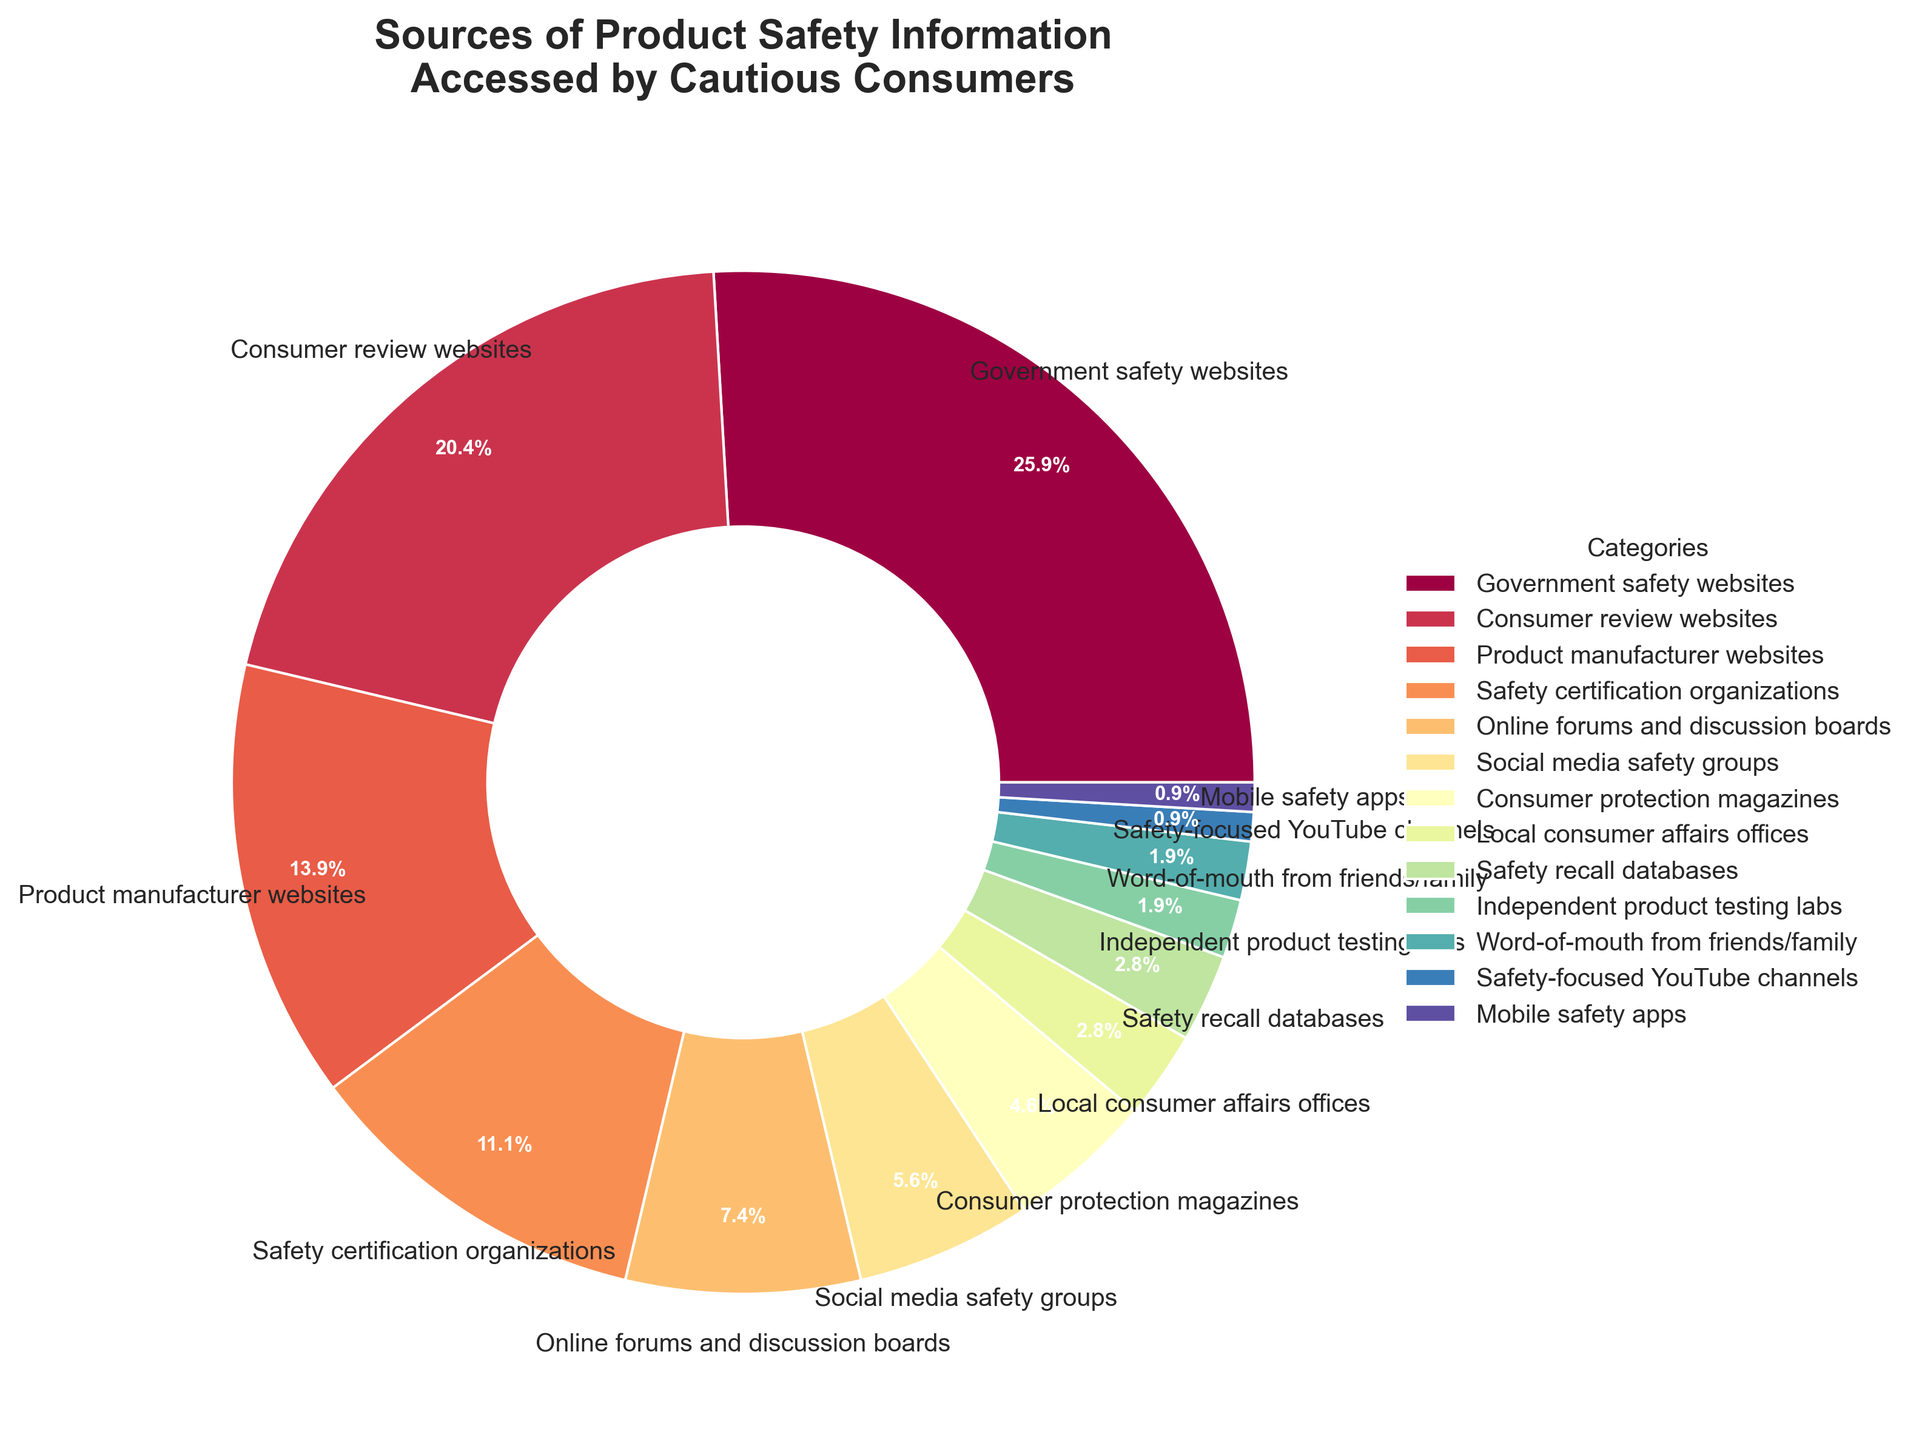What is the most common source of product safety information accessed by cautious consumers? The largest segment in the pie chart represents the most common source. The "Government safety websites" section is the largest at 28%.
Answer: Government safety websites How much more popular are Consumer review websites compared to Product manufacturer websites as sources of product safety information? Compare the percentages for "Consumer review websites" and "Product manufacturer websites". Consumer review websites are at 22% and Product manufacturer websites are at 15%. 22% - 15% = 7%
Answer: 7% What is the total percentage for online-based sources of product safety information (combining Consumer review websites, Online forums and discussion boards, Social media safety groups, and Mobile safety apps)? Sum the percentages for the relevant categories: Consumer review websites (22%) + Online forums and discussion boards (8%) + Social media safety groups (6%) + Mobile safety apps (1%). Total = 22% + 8% + 6% + 1% = 37%
Answer: 37% Which sources are equally accessed by cautious consumers for product safety information, according to the figure? Look for categories with the same percentage values. "Local consumer affairs offices" and "Safety recall databases" both have 3%, and "Word-of-mouth from friends/family" and "Safety-focused YouTube channels" both have 2%.
Answer: Local consumer affairs offices and Safety recall databases; Word-of-mouth from friends/family and Safety-focused YouTube channels How many sources are represented by less than 5% of the entire data? Count the categories with percentages less than 5%. They are: Consumer protection magazines (5%), Local consumer affairs offices (3%), Safety recall databases (3%), Independent product testing labs (2%), Word-of-mouth from friends/family (2%), Safety-focused YouTube channels (1%), Mobile safety apps (1%). There are seven sources.
Answer: 7 